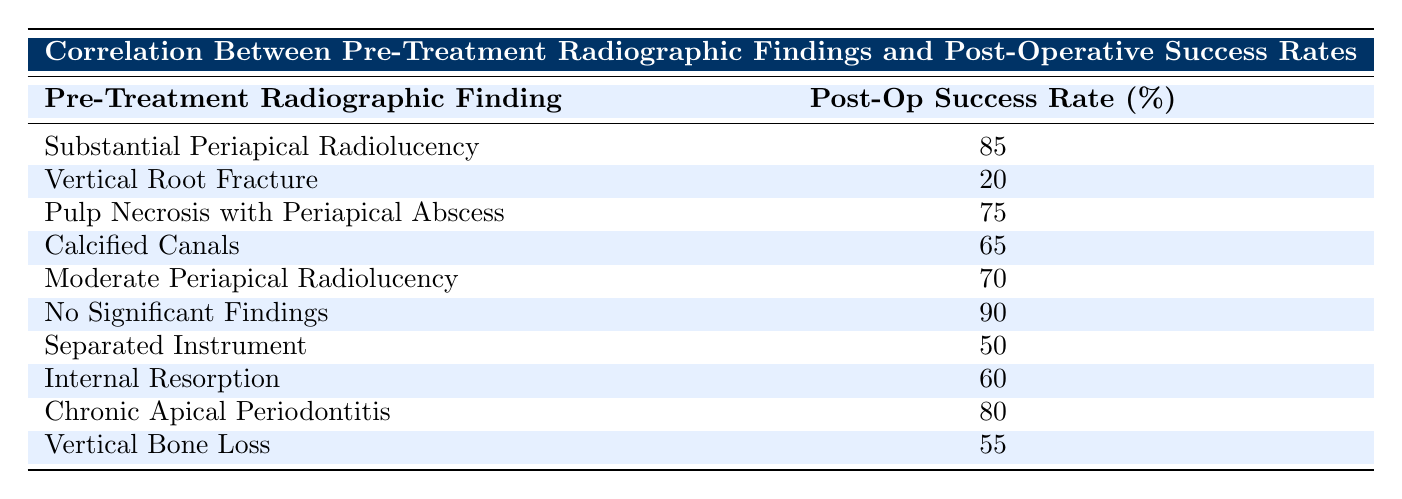What is the post-operative success rate for cases with substantial periapical radiolucency? The table indicates that the post-operative success rate for cases with substantial periapical radiolucency is listed as 85%.
Answer: 85 How many cases show a post-operative success rate below 60%? Looking through the table, there are two cases listed with a post-operative success rate below 60%: vertical root fracture (20%) and separated instrument (50%).
Answer: 2 What is the post-operative success rate for pulp necrosis with periapical abscess and how does it compare to internal resorption? The post-operative success rate for pulp necrosis with periapical abscess is 75%, whereas the rate for internal resorption is 60%. Comparing these two rates shows that pulp necrosis has a higher success rate by 15%.
Answer: 75, higher by 15% Is there a recorded case where no significant findings resulted in a post-operative success rate of 90%? According to the table, yes, there is a case where no significant findings resulted in a post-operative success rate of 90%.
Answer: Yes What is the average post-operative success rate of all recorded cases? To calculate the average, sum all success rates (85 + 20 + 75 + 65 + 70 + 90 + 50 + 60 + 80 + 55 =  80) and divide by the number of cases (10). So the average is 800/10 = 80%.
Answer: 80 If a case of chronic apical periodontitis has a success rate of 80%, how does this compare to the success rate of calcified canals? Chronic apical periodontitis has a success rate of 80%, while calcified canals have a success rate of 65%. Therefore, chronic apical periodontitis has a higher success rate by 15%.
Answer: 15 Which pre-treatment finding has the highest post-operative success rate? The highest recorded post-operative success rate in the table is for cases with no significant findings, which is 90%.
Answer: 90 What is the success rate difference between cases with moderate periapical radiolucency and those with vertical root fracture? Moderate periapical radiolucency has a success rate of 70%, and vertical root fracture has 20%. The difference in their success rates is 70 - 20 = 50%.
Answer: 50 